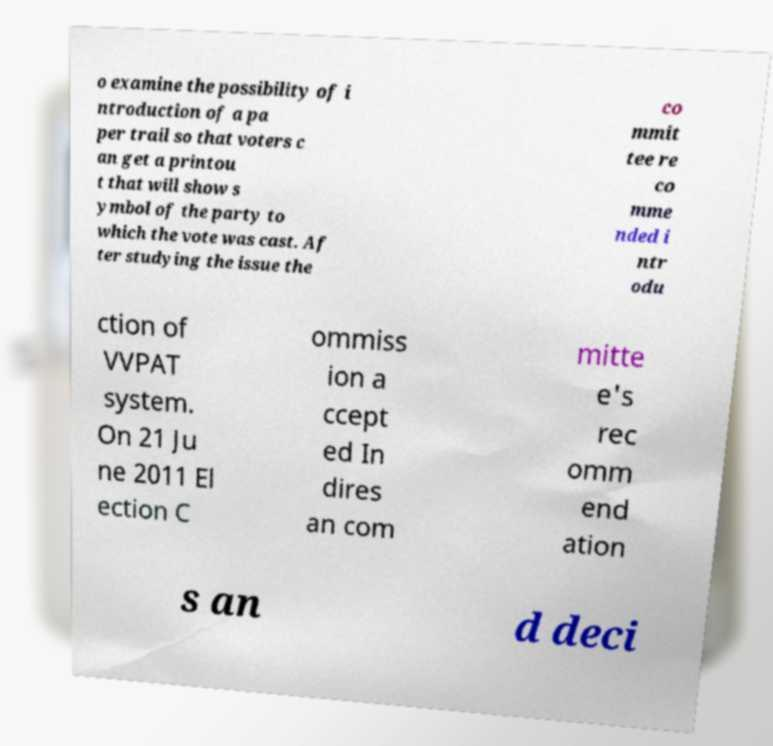Could you assist in decoding the text presented in this image and type it out clearly? o examine the possibility of i ntroduction of a pa per trail so that voters c an get a printou t that will show s ymbol of the party to which the vote was cast. Af ter studying the issue the co mmit tee re co mme nded i ntr odu ction of VVPAT system. On 21 Ju ne 2011 El ection C ommiss ion a ccept ed In dires an com mitte e's rec omm end ation s an d deci 